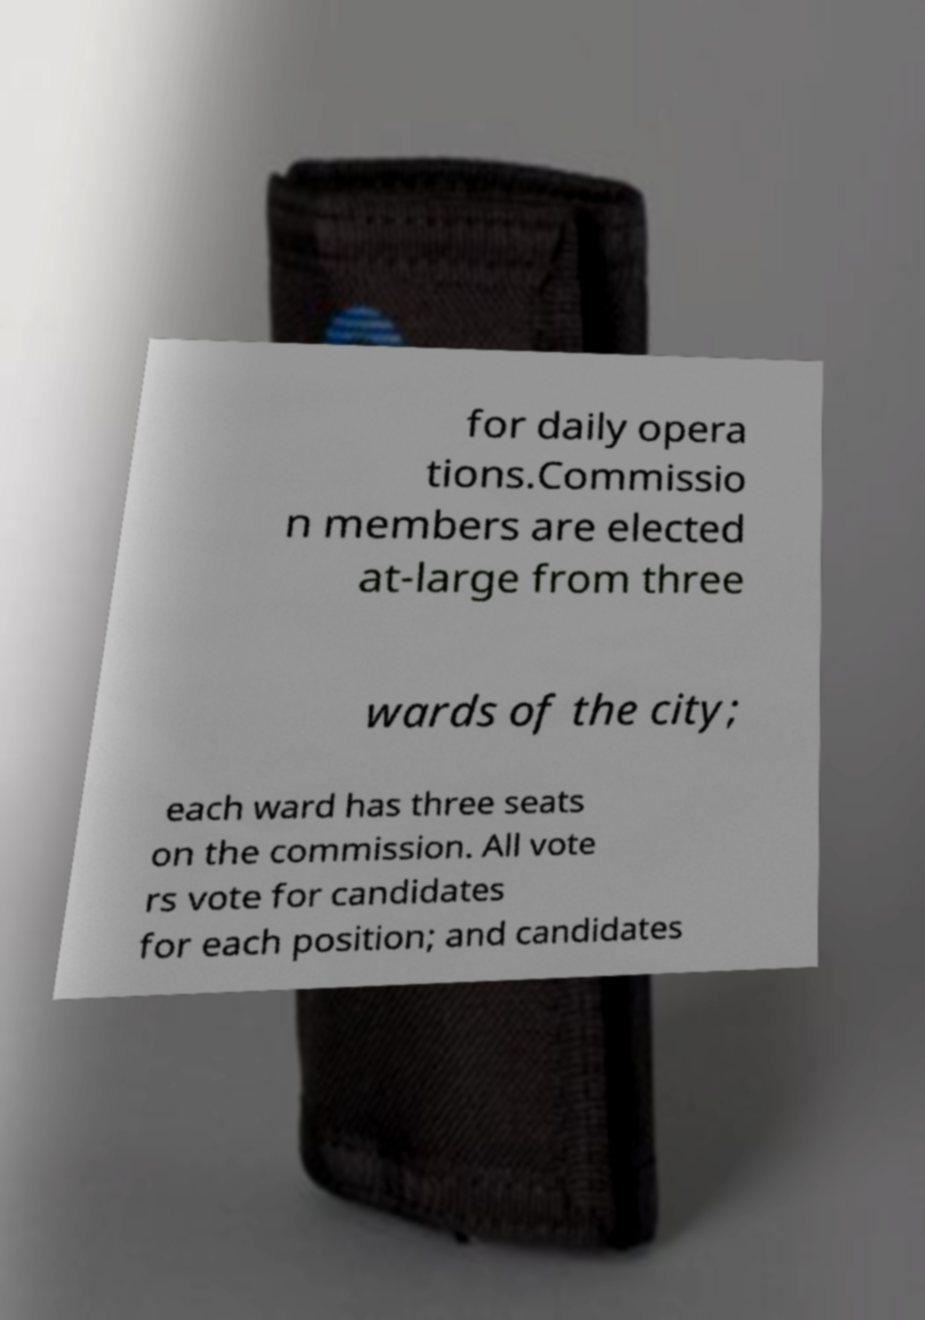Please read and relay the text visible in this image. What does it say? for daily opera tions.Commissio n members are elected at-large from three wards of the city; each ward has three seats on the commission. All vote rs vote for candidates for each position; and candidates 